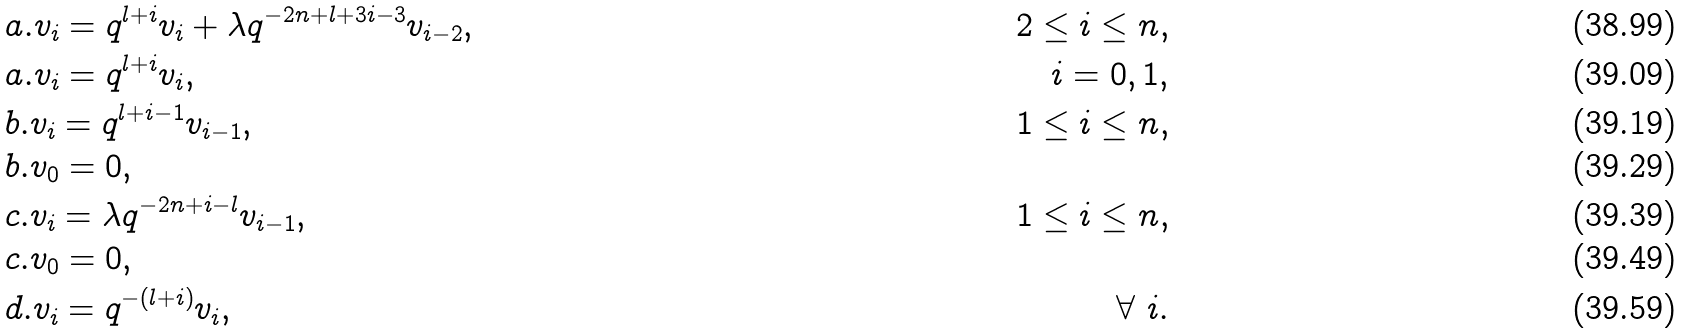<formula> <loc_0><loc_0><loc_500><loc_500>& a . v _ { i } = q ^ { l + i } v _ { i } + \lambda q ^ { - 2 n + l + 3 i - 3 } v _ { i - 2 } , & \quad 2 \leq i \leq n , \\ & a . v _ { i } = q ^ { l + i } v _ { i } , & \quad i = 0 , 1 , \\ & b . v _ { i } = q ^ { l + i - 1 } v _ { i - 1 } , & \quad 1 \leq i \leq n , \\ & b . v _ { 0 } = 0 , \\ & c . v _ { i } = \lambda q ^ { - 2 n + i - l } v _ { i - 1 } , & \quad 1 \leq i \leq n , \\ & c . v _ { 0 } = 0 , \\ & d . v _ { i } = q ^ { - ( l + i ) } v _ { i } , & \quad \forall \ i .</formula> 